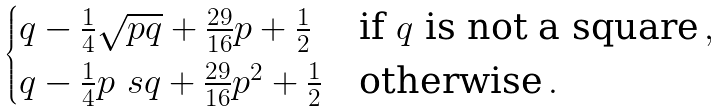Convert formula to latex. <formula><loc_0><loc_0><loc_500><loc_500>\begin{cases} q - \frac { 1 } { 4 } \sqrt { p q } + \frac { 2 9 } { 1 6 } p + \frac { 1 } { 2 } & \text {if $q$ is not a square} \, , \\ q - \frac { 1 } { 4 } p \ s q + \frac { 2 9 } { 1 6 } p ^ { 2 } + \frac { 1 } { 2 } & \text {otherwise} \, . \end{cases}</formula> 